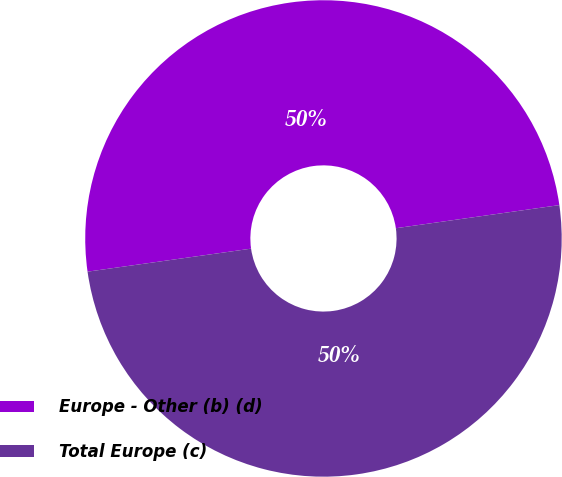Convert chart. <chart><loc_0><loc_0><loc_500><loc_500><pie_chart><fcel>Europe - Other (b) (d)<fcel>Total Europe (c)<nl><fcel>49.99%<fcel>50.01%<nl></chart> 